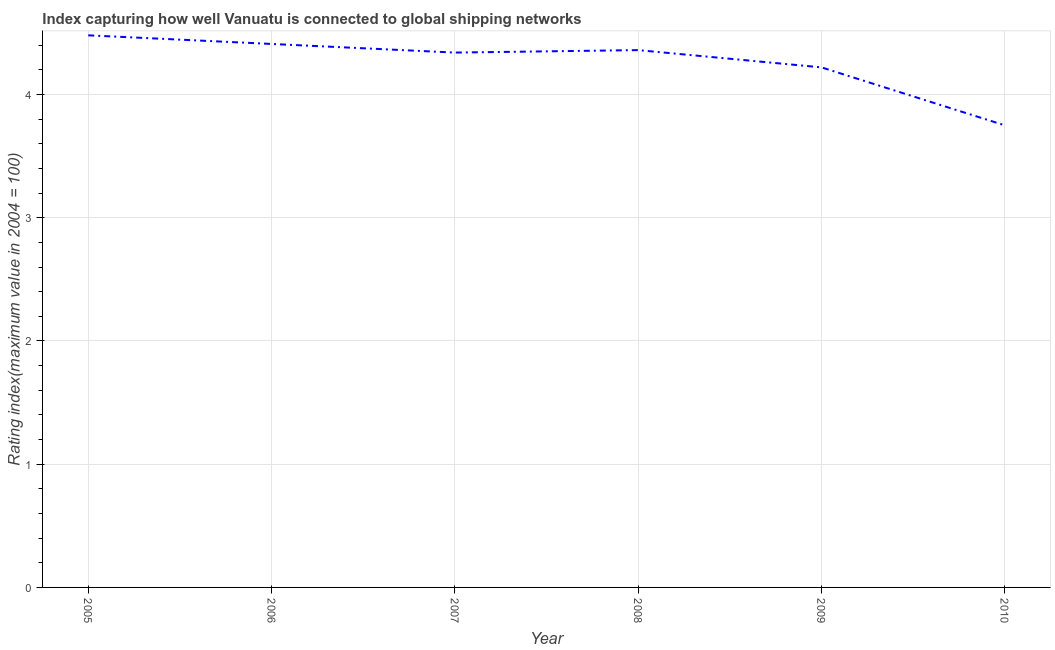What is the liner shipping connectivity index in 2009?
Keep it short and to the point. 4.22. Across all years, what is the maximum liner shipping connectivity index?
Offer a terse response. 4.48. Across all years, what is the minimum liner shipping connectivity index?
Keep it short and to the point. 3.75. In which year was the liner shipping connectivity index minimum?
Ensure brevity in your answer.  2010. What is the sum of the liner shipping connectivity index?
Make the answer very short. 25.56. What is the difference between the liner shipping connectivity index in 2005 and 2008?
Your answer should be very brief. 0.12. What is the average liner shipping connectivity index per year?
Your answer should be compact. 4.26. What is the median liner shipping connectivity index?
Keep it short and to the point. 4.35. Do a majority of the years between 2010 and 2008 (inclusive) have liner shipping connectivity index greater than 0.2 ?
Make the answer very short. No. What is the ratio of the liner shipping connectivity index in 2007 to that in 2008?
Provide a short and direct response. 1. Is the liner shipping connectivity index in 2007 less than that in 2009?
Keep it short and to the point. No. Is the difference between the liner shipping connectivity index in 2005 and 2007 greater than the difference between any two years?
Offer a very short reply. No. What is the difference between the highest and the second highest liner shipping connectivity index?
Offer a terse response. 0.07. Is the sum of the liner shipping connectivity index in 2005 and 2009 greater than the maximum liner shipping connectivity index across all years?
Your response must be concise. Yes. What is the difference between the highest and the lowest liner shipping connectivity index?
Offer a very short reply. 0.73. Does the liner shipping connectivity index monotonically increase over the years?
Provide a succinct answer. No. How many years are there in the graph?
Offer a terse response. 6. Does the graph contain grids?
Your response must be concise. Yes. What is the title of the graph?
Provide a succinct answer. Index capturing how well Vanuatu is connected to global shipping networks. What is the label or title of the Y-axis?
Keep it short and to the point. Rating index(maximum value in 2004 = 100). What is the Rating index(maximum value in 2004 = 100) of 2005?
Offer a terse response. 4.48. What is the Rating index(maximum value in 2004 = 100) of 2006?
Ensure brevity in your answer.  4.41. What is the Rating index(maximum value in 2004 = 100) of 2007?
Give a very brief answer. 4.34. What is the Rating index(maximum value in 2004 = 100) in 2008?
Your answer should be compact. 4.36. What is the Rating index(maximum value in 2004 = 100) in 2009?
Offer a terse response. 4.22. What is the Rating index(maximum value in 2004 = 100) in 2010?
Ensure brevity in your answer.  3.75. What is the difference between the Rating index(maximum value in 2004 = 100) in 2005 and 2006?
Keep it short and to the point. 0.07. What is the difference between the Rating index(maximum value in 2004 = 100) in 2005 and 2007?
Keep it short and to the point. 0.14. What is the difference between the Rating index(maximum value in 2004 = 100) in 2005 and 2008?
Provide a succinct answer. 0.12. What is the difference between the Rating index(maximum value in 2004 = 100) in 2005 and 2009?
Keep it short and to the point. 0.26. What is the difference between the Rating index(maximum value in 2004 = 100) in 2005 and 2010?
Offer a terse response. 0.73. What is the difference between the Rating index(maximum value in 2004 = 100) in 2006 and 2007?
Give a very brief answer. 0.07. What is the difference between the Rating index(maximum value in 2004 = 100) in 2006 and 2009?
Your answer should be compact. 0.19. What is the difference between the Rating index(maximum value in 2004 = 100) in 2006 and 2010?
Offer a terse response. 0.66. What is the difference between the Rating index(maximum value in 2004 = 100) in 2007 and 2008?
Offer a very short reply. -0.02. What is the difference between the Rating index(maximum value in 2004 = 100) in 2007 and 2009?
Offer a very short reply. 0.12. What is the difference between the Rating index(maximum value in 2004 = 100) in 2007 and 2010?
Offer a very short reply. 0.59. What is the difference between the Rating index(maximum value in 2004 = 100) in 2008 and 2009?
Provide a succinct answer. 0.14. What is the difference between the Rating index(maximum value in 2004 = 100) in 2008 and 2010?
Your answer should be very brief. 0.61. What is the difference between the Rating index(maximum value in 2004 = 100) in 2009 and 2010?
Give a very brief answer. 0.47. What is the ratio of the Rating index(maximum value in 2004 = 100) in 2005 to that in 2006?
Offer a very short reply. 1.02. What is the ratio of the Rating index(maximum value in 2004 = 100) in 2005 to that in 2007?
Your answer should be very brief. 1.03. What is the ratio of the Rating index(maximum value in 2004 = 100) in 2005 to that in 2008?
Ensure brevity in your answer.  1.03. What is the ratio of the Rating index(maximum value in 2004 = 100) in 2005 to that in 2009?
Your answer should be compact. 1.06. What is the ratio of the Rating index(maximum value in 2004 = 100) in 2005 to that in 2010?
Provide a succinct answer. 1.2. What is the ratio of the Rating index(maximum value in 2004 = 100) in 2006 to that in 2009?
Keep it short and to the point. 1.04. What is the ratio of the Rating index(maximum value in 2004 = 100) in 2006 to that in 2010?
Your response must be concise. 1.18. What is the ratio of the Rating index(maximum value in 2004 = 100) in 2007 to that in 2009?
Your response must be concise. 1.03. What is the ratio of the Rating index(maximum value in 2004 = 100) in 2007 to that in 2010?
Your response must be concise. 1.16. What is the ratio of the Rating index(maximum value in 2004 = 100) in 2008 to that in 2009?
Keep it short and to the point. 1.03. What is the ratio of the Rating index(maximum value in 2004 = 100) in 2008 to that in 2010?
Give a very brief answer. 1.16. 